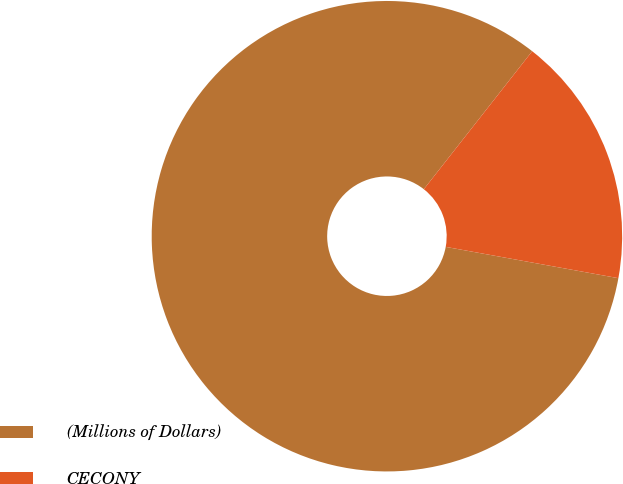Convert chart. <chart><loc_0><loc_0><loc_500><loc_500><pie_chart><fcel>(Millions of Dollars)<fcel>CECONY<nl><fcel>82.74%<fcel>17.26%<nl></chart> 